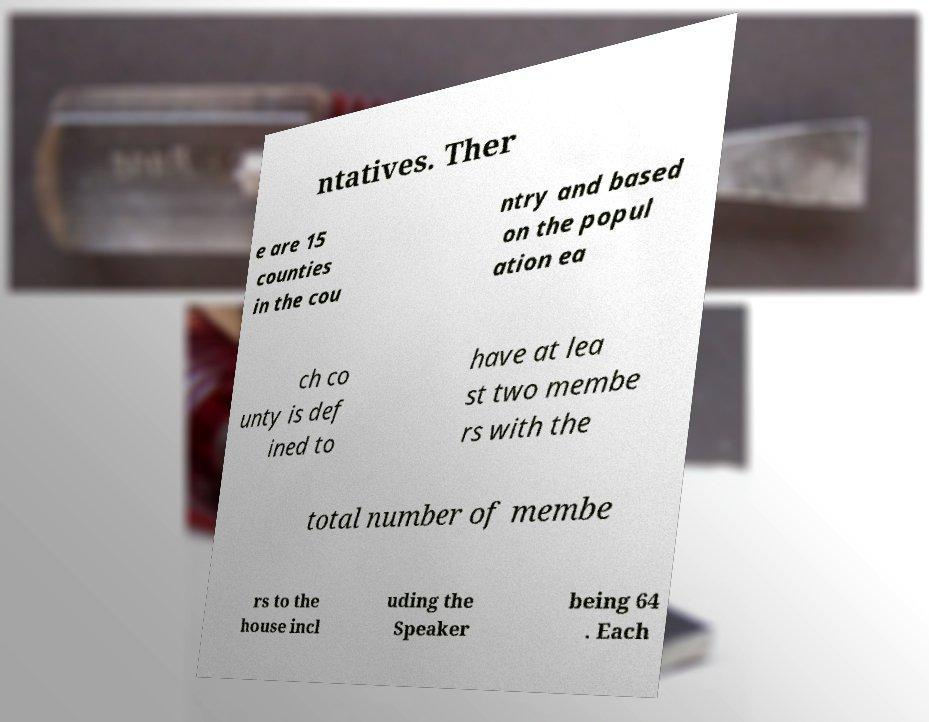Can you read and provide the text displayed in the image?This photo seems to have some interesting text. Can you extract and type it out for me? ntatives. Ther e are 15 counties in the cou ntry and based on the popul ation ea ch co unty is def ined to have at lea st two membe rs with the total number of membe rs to the house incl uding the Speaker being 64 . Each 